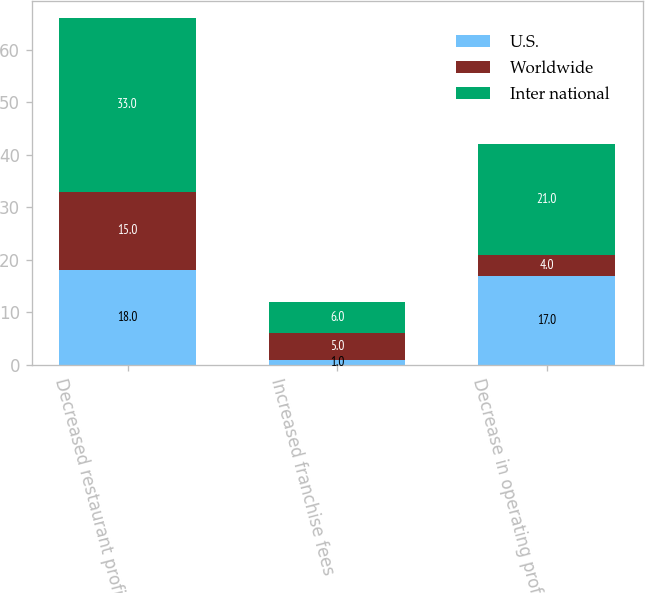Convert chart. <chart><loc_0><loc_0><loc_500><loc_500><stacked_bar_chart><ecel><fcel>Decreased restaurant profit<fcel>Increased franchise fees<fcel>Decrease in operating profit<nl><fcel>U.S.<fcel>18<fcel>1<fcel>17<nl><fcel>Worldwide<fcel>15<fcel>5<fcel>4<nl><fcel>Inter national<fcel>33<fcel>6<fcel>21<nl></chart> 